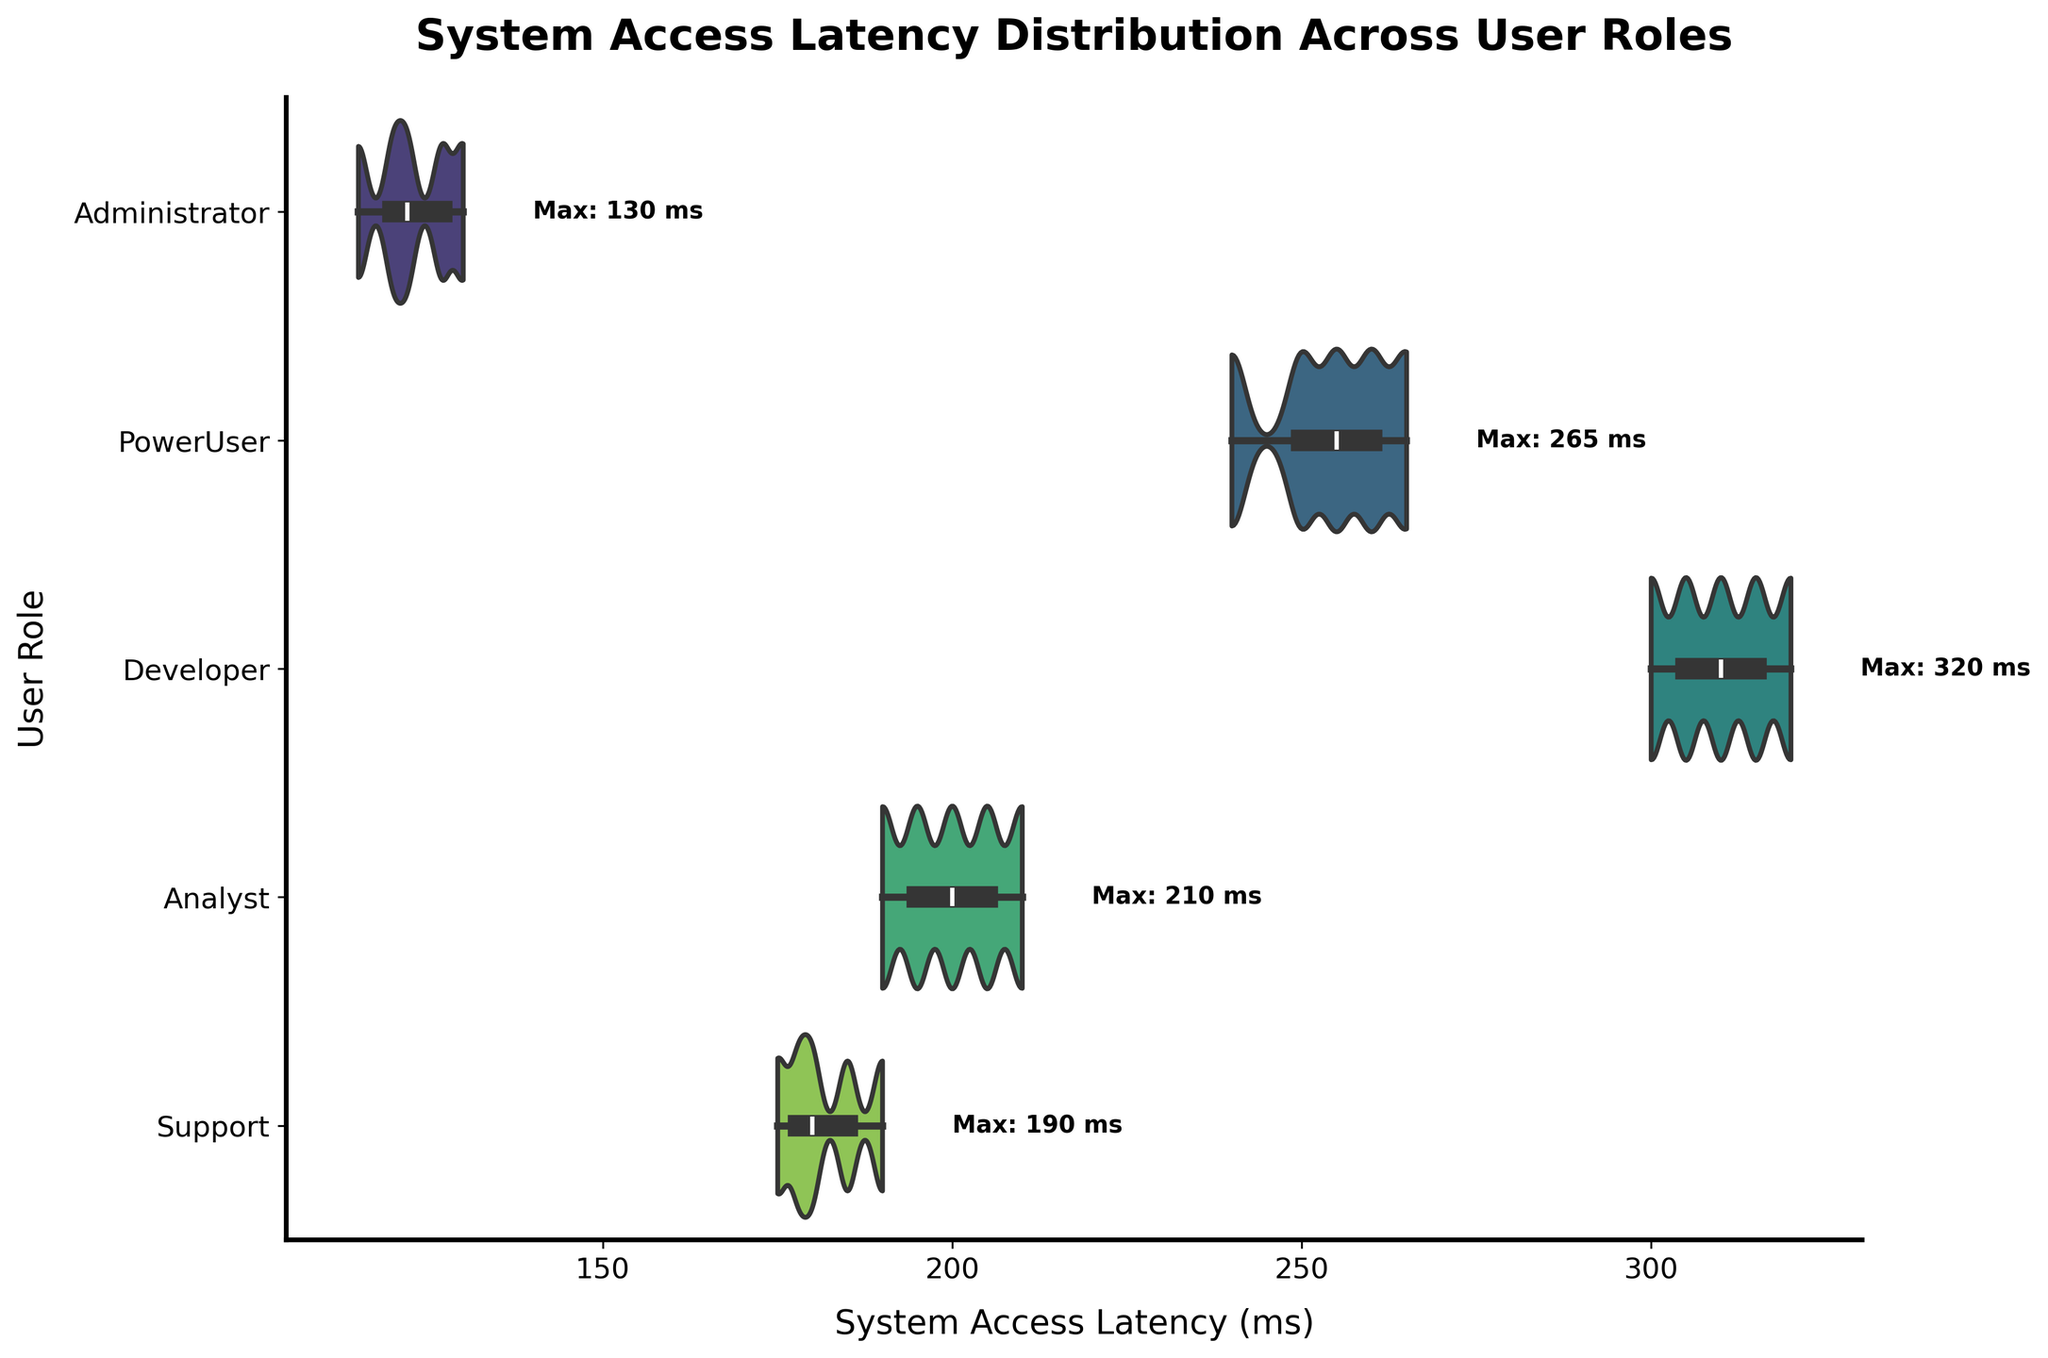What's the title of the plot? The title of the plot is displayed prominently at the top. It is written in bold and large font size.
Answer: System Access Latency Distribution Across User Roles Which user role has the smallest maximum system access latency? By reading the text annotations next to the maximum values of system access latency for each user role, we can determine the role with the smallest maximum value.
Answer: Administrator What is the range of system access latency for Developers? To find the range, identify the minimum and maximum latency values for Developers from the plot and subtract the minimum from the maximum.
Answer: 320 - 300 = 20 ms Which user role experiences the highest variation in system access latency? The width and spread of the violins indicate the variation in latency. A wider and more spread-out shape indicates higher variation.
Answer: Developer How does the maximum latency for Administrators compare to that for Power Users? Compare the text annotations for the maximum latency values indicated next to the violins for Administrators and Power Users.
Answer: Administrator: 130 ms, PowerUser: 265 ms; 265 ms is greater than 130 ms Which user role has their access latency centered the lowest, visually? Look for the violin plot that is centered around the lowest values on the x-axis.
Answer: Administrator What's the average of the maximum latency between Analysts and Supports? Add the maximum latency values annotated for Analysts and Supports and then divide by 2 to find the average.
Answer: (210 + 190) / 2 = 200 ms Which group has a higher and more spread out latency distribution, Power Users or Analysts? By comparing the shapes and spreads of the violin plots for Power Users and Analysts, we can determine which is higher and more spread out.
Answer: Power Users What is the general trend in system access latency from Administrators to Developers? Observe the shift in the center and spread of the latency distributions from left to right across the user roles.
Answer: Increasing trend 